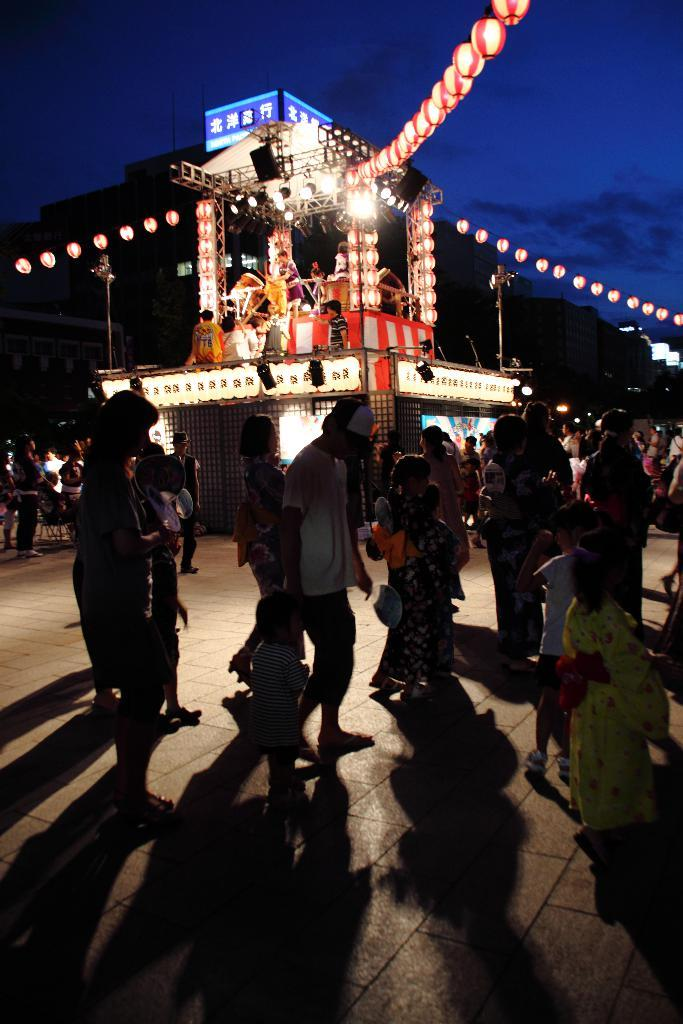What can be seen on the road in the image? There are persons on the road in the image. What else is visible in the image besides the persons on the road? There are lights, poles, boards, buildings, and the sky visible in the image. Can you describe the lights in the image? The lights are visible, but their specific type or purpose cannot be determined from the image. What is the background of the image? The sky is visible in the background of the image. What type of jelly is being served on the tray in the image? There is no tray or jelly present in the image. How does the person on the road walk in the image? The image does not show the person walking; it only shows them standing on the road. 